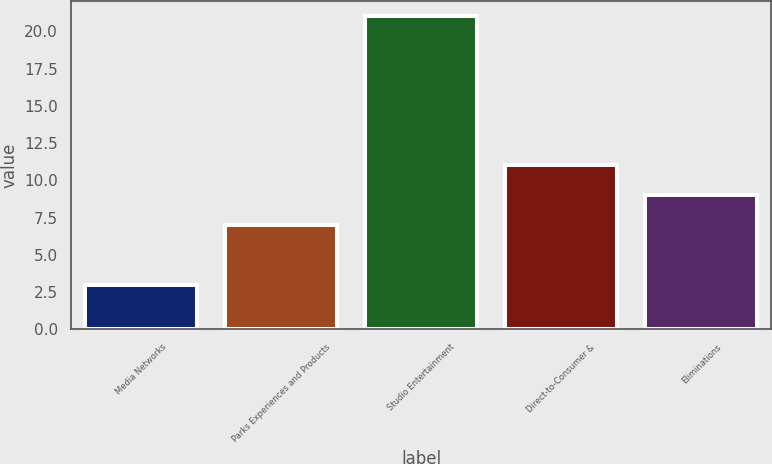Convert chart to OTSL. <chart><loc_0><loc_0><loc_500><loc_500><bar_chart><fcel>Media Networks<fcel>Parks Experiences and Products<fcel>Studio Entertainment<fcel>Direct-to-Consumer &<fcel>Eliminations<nl><fcel>3<fcel>7<fcel>21<fcel>11<fcel>9<nl></chart> 